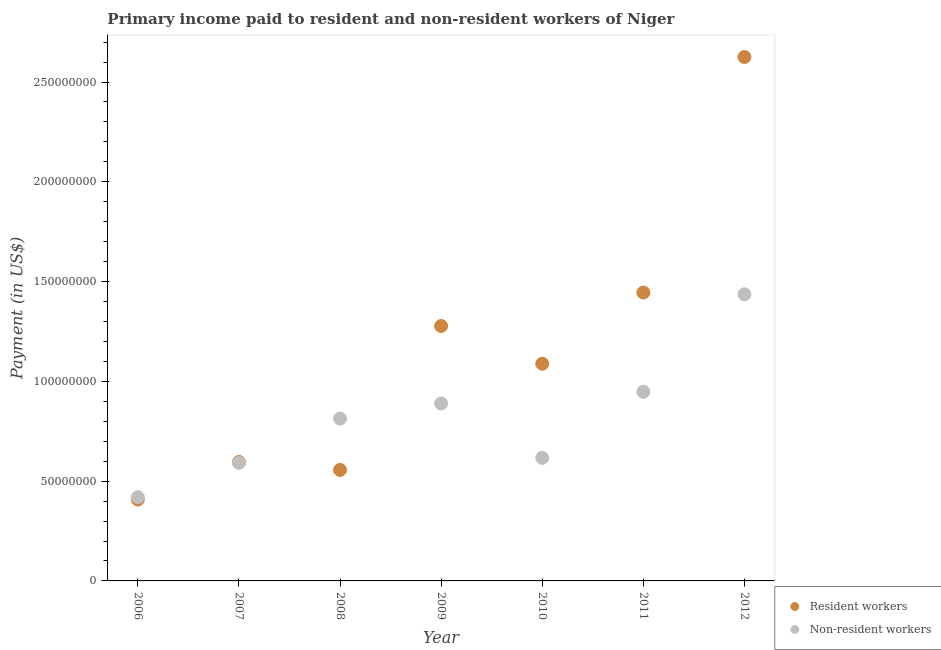How many different coloured dotlines are there?
Keep it short and to the point. 2. Is the number of dotlines equal to the number of legend labels?
Make the answer very short. Yes. What is the payment made to resident workers in 2012?
Provide a succinct answer. 2.63e+08. Across all years, what is the maximum payment made to non-resident workers?
Make the answer very short. 1.44e+08. Across all years, what is the minimum payment made to non-resident workers?
Make the answer very short. 4.20e+07. What is the total payment made to resident workers in the graph?
Give a very brief answer. 8.00e+08. What is the difference between the payment made to non-resident workers in 2007 and that in 2011?
Provide a succinct answer. -3.56e+07. What is the difference between the payment made to non-resident workers in 2007 and the payment made to resident workers in 2009?
Ensure brevity in your answer.  -6.86e+07. What is the average payment made to non-resident workers per year?
Ensure brevity in your answer.  8.17e+07. In the year 2011, what is the difference between the payment made to resident workers and payment made to non-resident workers?
Offer a terse response. 4.97e+07. What is the ratio of the payment made to non-resident workers in 2008 to that in 2010?
Give a very brief answer. 1.32. Is the difference between the payment made to resident workers in 2007 and 2008 greater than the difference between the payment made to non-resident workers in 2007 and 2008?
Offer a very short reply. Yes. What is the difference between the highest and the second highest payment made to resident workers?
Provide a short and direct response. 1.18e+08. What is the difference between the highest and the lowest payment made to non-resident workers?
Keep it short and to the point. 1.02e+08. Is the sum of the payment made to non-resident workers in 2009 and 2010 greater than the maximum payment made to resident workers across all years?
Make the answer very short. No. Is the payment made to non-resident workers strictly greater than the payment made to resident workers over the years?
Keep it short and to the point. No. How many dotlines are there?
Your answer should be compact. 2. What is the difference between two consecutive major ticks on the Y-axis?
Offer a terse response. 5.00e+07. Where does the legend appear in the graph?
Your answer should be compact. Bottom right. How many legend labels are there?
Offer a very short reply. 2. How are the legend labels stacked?
Keep it short and to the point. Vertical. What is the title of the graph?
Make the answer very short. Primary income paid to resident and non-resident workers of Niger. What is the label or title of the X-axis?
Keep it short and to the point. Year. What is the label or title of the Y-axis?
Ensure brevity in your answer.  Payment (in US$). What is the Payment (in US$) of Resident workers in 2006?
Your answer should be very brief. 4.08e+07. What is the Payment (in US$) of Non-resident workers in 2006?
Provide a succinct answer. 4.20e+07. What is the Payment (in US$) in Resident workers in 2007?
Your answer should be compact. 5.96e+07. What is the Payment (in US$) in Non-resident workers in 2007?
Your answer should be very brief. 5.92e+07. What is the Payment (in US$) of Resident workers in 2008?
Your response must be concise. 5.56e+07. What is the Payment (in US$) of Non-resident workers in 2008?
Provide a succinct answer. 8.13e+07. What is the Payment (in US$) in Resident workers in 2009?
Make the answer very short. 1.28e+08. What is the Payment (in US$) in Non-resident workers in 2009?
Offer a very short reply. 8.89e+07. What is the Payment (in US$) in Resident workers in 2010?
Your answer should be compact. 1.09e+08. What is the Payment (in US$) of Non-resident workers in 2010?
Ensure brevity in your answer.  6.17e+07. What is the Payment (in US$) of Resident workers in 2011?
Ensure brevity in your answer.  1.45e+08. What is the Payment (in US$) of Non-resident workers in 2011?
Offer a terse response. 9.48e+07. What is the Payment (in US$) in Resident workers in 2012?
Your answer should be compact. 2.63e+08. What is the Payment (in US$) of Non-resident workers in 2012?
Offer a very short reply. 1.44e+08. Across all years, what is the maximum Payment (in US$) of Resident workers?
Provide a succinct answer. 2.63e+08. Across all years, what is the maximum Payment (in US$) of Non-resident workers?
Provide a succinct answer. 1.44e+08. Across all years, what is the minimum Payment (in US$) of Resident workers?
Your answer should be very brief. 4.08e+07. Across all years, what is the minimum Payment (in US$) of Non-resident workers?
Your response must be concise. 4.20e+07. What is the total Payment (in US$) of Resident workers in the graph?
Your response must be concise. 8.00e+08. What is the total Payment (in US$) in Non-resident workers in the graph?
Provide a succinct answer. 5.72e+08. What is the difference between the Payment (in US$) of Resident workers in 2006 and that in 2007?
Your response must be concise. -1.89e+07. What is the difference between the Payment (in US$) of Non-resident workers in 2006 and that in 2007?
Make the answer very short. -1.72e+07. What is the difference between the Payment (in US$) in Resident workers in 2006 and that in 2008?
Ensure brevity in your answer.  -1.48e+07. What is the difference between the Payment (in US$) of Non-resident workers in 2006 and that in 2008?
Keep it short and to the point. -3.94e+07. What is the difference between the Payment (in US$) in Resident workers in 2006 and that in 2009?
Provide a succinct answer. -8.70e+07. What is the difference between the Payment (in US$) in Non-resident workers in 2006 and that in 2009?
Ensure brevity in your answer.  -4.70e+07. What is the difference between the Payment (in US$) in Resident workers in 2006 and that in 2010?
Provide a succinct answer. -6.81e+07. What is the difference between the Payment (in US$) of Non-resident workers in 2006 and that in 2010?
Provide a succinct answer. -1.97e+07. What is the difference between the Payment (in US$) of Resident workers in 2006 and that in 2011?
Your answer should be very brief. -1.04e+08. What is the difference between the Payment (in US$) in Non-resident workers in 2006 and that in 2011?
Give a very brief answer. -5.28e+07. What is the difference between the Payment (in US$) in Resident workers in 2006 and that in 2012?
Offer a very short reply. -2.22e+08. What is the difference between the Payment (in US$) in Non-resident workers in 2006 and that in 2012?
Offer a terse response. -1.02e+08. What is the difference between the Payment (in US$) of Resident workers in 2007 and that in 2008?
Your answer should be compact. 4.01e+06. What is the difference between the Payment (in US$) in Non-resident workers in 2007 and that in 2008?
Your response must be concise. -2.22e+07. What is the difference between the Payment (in US$) of Resident workers in 2007 and that in 2009?
Provide a succinct answer. -6.81e+07. What is the difference between the Payment (in US$) of Non-resident workers in 2007 and that in 2009?
Give a very brief answer. -2.98e+07. What is the difference between the Payment (in US$) in Resident workers in 2007 and that in 2010?
Offer a very short reply. -4.92e+07. What is the difference between the Payment (in US$) in Non-resident workers in 2007 and that in 2010?
Give a very brief answer. -2.50e+06. What is the difference between the Payment (in US$) in Resident workers in 2007 and that in 2011?
Make the answer very short. -8.49e+07. What is the difference between the Payment (in US$) of Non-resident workers in 2007 and that in 2011?
Your response must be concise. -3.56e+07. What is the difference between the Payment (in US$) in Resident workers in 2007 and that in 2012?
Provide a short and direct response. -2.03e+08. What is the difference between the Payment (in US$) of Non-resident workers in 2007 and that in 2012?
Provide a short and direct response. -8.44e+07. What is the difference between the Payment (in US$) in Resident workers in 2008 and that in 2009?
Ensure brevity in your answer.  -7.21e+07. What is the difference between the Payment (in US$) of Non-resident workers in 2008 and that in 2009?
Provide a succinct answer. -7.60e+06. What is the difference between the Payment (in US$) in Resident workers in 2008 and that in 2010?
Your answer should be compact. -5.32e+07. What is the difference between the Payment (in US$) in Non-resident workers in 2008 and that in 2010?
Make the answer very short. 1.96e+07. What is the difference between the Payment (in US$) in Resident workers in 2008 and that in 2011?
Offer a very short reply. -8.89e+07. What is the difference between the Payment (in US$) in Non-resident workers in 2008 and that in 2011?
Your response must be concise. -1.35e+07. What is the difference between the Payment (in US$) of Resident workers in 2008 and that in 2012?
Your response must be concise. -2.07e+08. What is the difference between the Payment (in US$) of Non-resident workers in 2008 and that in 2012?
Your response must be concise. -6.23e+07. What is the difference between the Payment (in US$) of Resident workers in 2009 and that in 2010?
Make the answer very short. 1.89e+07. What is the difference between the Payment (in US$) of Non-resident workers in 2009 and that in 2010?
Make the answer very short. 2.73e+07. What is the difference between the Payment (in US$) in Resident workers in 2009 and that in 2011?
Make the answer very short. -1.68e+07. What is the difference between the Payment (in US$) in Non-resident workers in 2009 and that in 2011?
Keep it short and to the point. -5.86e+06. What is the difference between the Payment (in US$) in Resident workers in 2009 and that in 2012?
Your answer should be very brief. -1.35e+08. What is the difference between the Payment (in US$) in Non-resident workers in 2009 and that in 2012?
Your answer should be very brief. -5.47e+07. What is the difference between the Payment (in US$) in Resident workers in 2010 and that in 2011?
Offer a terse response. -3.57e+07. What is the difference between the Payment (in US$) in Non-resident workers in 2010 and that in 2011?
Make the answer very short. -3.31e+07. What is the difference between the Payment (in US$) of Resident workers in 2010 and that in 2012?
Provide a succinct answer. -1.54e+08. What is the difference between the Payment (in US$) of Non-resident workers in 2010 and that in 2012?
Your answer should be compact. -8.19e+07. What is the difference between the Payment (in US$) of Resident workers in 2011 and that in 2012?
Your answer should be very brief. -1.18e+08. What is the difference between the Payment (in US$) in Non-resident workers in 2011 and that in 2012?
Give a very brief answer. -4.88e+07. What is the difference between the Payment (in US$) of Resident workers in 2006 and the Payment (in US$) of Non-resident workers in 2007?
Ensure brevity in your answer.  -1.84e+07. What is the difference between the Payment (in US$) of Resident workers in 2006 and the Payment (in US$) of Non-resident workers in 2008?
Make the answer very short. -4.06e+07. What is the difference between the Payment (in US$) of Resident workers in 2006 and the Payment (in US$) of Non-resident workers in 2009?
Keep it short and to the point. -4.82e+07. What is the difference between the Payment (in US$) of Resident workers in 2006 and the Payment (in US$) of Non-resident workers in 2010?
Ensure brevity in your answer.  -2.09e+07. What is the difference between the Payment (in US$) of Resident workers in 2006 and the Payment (in US$) of Non-resident workers in 2011?
Provide a short and direct response. -5.40e+07. What is the difference between the Payment (in US$) of Resident workers in 2006 and the Payment (in US$) of Non-resident workers in 2012?
Offer a terse response. -1.03e+08. What is the difference between the Payment (in US$) in Resident workers in 2007 and the Payment (in US$) in Non-resident workers in 2008?
Your answer should be very brief. -2.17e+07. What is the difference between the Payment (in US$) of Resident workers in 2007 and the Payment (in US$) of Non-resident workers in 2009?
Ensure brevity in your answer.  -2.93e+07. What is the difference between the Payment (in US$) in Resident workers in 2007 and the Payment (in US$) in Non-resident workers in 2010?
Ensure brevity in your answer.  -2.06e+06. What is the difference between the Payment (in US$) in Resident workers in 2007 and the Payment (in US$) in Non-resident workers in 2011?
Your answer should be compact. -3.52e+07. What is the difference between the Payment (in US$) of Resident workers in 2007 and the Payment (in US$) of Non-resident workers in 2012?
Provide a succinct answer. -8.40e+07. What is the difference between the Payment (in US$) of Resident workers in 2008 and the Payment (in US$) of Non-resident workers in 2009?
Your answer should be compact. -3.33e+07. What is the difference between the Payment (in US$) in Resident workers in 2008 and the Payment (in US$) in Non-resident workers in 2010?
Your response must be concise. -6.07e+06. What is the difference between the Payment (in US$) in Resident workers in 2008 and the Payment (in US$) in Non-resident workers in 2011?
Your answer should be very brief. -3.92e+07. What is the difference between the Payment (in US$) in Resident workers in 2008 and the Payment (in US$) in Non-resident workers in 2012?
Provide a succinct answer. -8.80e+07. What is the difference between the Payment (in US$) in Resident workers in 2009 and the Payment (in US$) in Non-resident workers in 2010?
Your response must be concise. 6.61e+07. What is the difference between the Payment (in US$) in Resident workers in 2009 and the Payment (in US$) in Non-resident workers in 2011?
Ensure brevity in your answer.  3.29e+07. What is the difference between the Payment (in US$) in Resident workers in 2009 and the Payment (in US$) in Non-resident workers in 2012?
Provide a short and direct response. -1.59e+07. What is the difference between the Payment (in US$) in Resident workers in 2010 and the Payment (in US$) in Non-resident workers in 2011?
Give a very brief answer. 1.41e+07. What is the difference between the Payment (in US$) of Resident workers in 2010 and the Payment (in US$) of Non-resident workers in 2012?
Provide a short and direct response. -3.48e+07. What is the difference between the Payment (in US$) of Resident workers in 2011 and the Payment (in US$) of Non-resident workers in 2012?
Your response must be concise. 8.73e+05. What is the average Payment (in US$) of Resident workers per year?
Make the answer very short. 1.14e+08. What is the average Payment (in US$) in Non-resident workers per year?
Give a very brief answer. 8.17e+07. In the year 2006, what is the difference between the Payment (in US$) of Resident workers and Payment (in US$) of Non-resident workers?
Provide a short and direct response. -1.21e+06. In the year 2007, what is the difference between the Payment (in US$) in Resident workers and Payment (in US$) in Non-resident workers?
Keep it short and to the point. 4.40e+05. In the year 2008, what is the difference between the Payment (in US$) of Resident workers and Payment (in US$) of Non-resident workers?
Offer a terse response. -2.57e+07. In the year 2009, what is the difference between the Payment (in US$) of Resident workers and Payment (in US$) of Non-resident workers?
Provide a succinct answer. 3.88e+07. In the year 2010, what is the difference between the Payment (in US$) of Resident workers and Payment (in US$) of Non-resident workers?
Your answer should be compact. 4.72e+07. In the year 2011, what is the difference between the Payment (in US$) in Resident workers and Payment (in US$) in Non-resident workers?
Make the answer very short. 4.97e+07. In the year 2012, what is the difference between the Payment (in US$) in Resident workers and Payment (in US$) in Non-resident workers?
Offer a very short reply. 1.19e+08. What is the ratio of the Payment (in US$) of Resident workers in 2006 to that in 2007?
Make the answer very short. 0.68. What is the ratio of the Payment (in US$) of Non-resident workers in 2006 to that in 2007?
Keep it short and to the point. 0.71. What is the ratio of the Payment (in US$) of Resident workers in 2006 to that in 2008?
Give a very brief answer. 0.73. What is the ratio of the Payment (in US$) of Non-resident workers in 2006 to that in 2008?
Offer a very short reply. 0.52. What is the ratio of the Payment (in US$) in Resident workers in 2006 to that in 2009?
Make the answer very short. 0.32. What is the ratio of the Payment (in US$) in Non-resident workers in 2006 to that in 2009?
Keep it short and to the point. 0.47. What is the ratio of the Payment (in US$) in Resident workers in 2006 to that in 2010?
Your response must be concise. 0.37. What is the ratio of the Payment (in US$) in Non-resident workers in 2006 to that in 2010?
Your response must be concise. 0.68. What is the ratio of the Payment (in US$) in Resident workers in 2006 to that in 2011?
Offer a very short reply. 0.28. What is the ratio of the Payment (in US$) in Non-resident workers in 2006 to that in 2011?
Provide a succinct answer. 0.44. What is the ratio of the Payment (in US$) in Resident workers in 2006 to that in 2012?
Provide a short and direct response. 0.16. What is the ratio of the Payment (in US$) in Non-resident workers in 2006 to that in 2012?
Provide a succinct answer. 0.29. What is the ratio of the Payment (in US$) of Resident workers in 2007 to that in 2008?
Provide a short and direct response. 1.07. What is the ratio of the Payment (in US$) of Non-resident workers in 2007 to that in 2008?
Your answer should be very brief. 0.73. What is the ratio of the Payment (in US$) in Resident workers in 2007 to that in 2009?
Make the answer very short. 0.47. What is the ratio of the Payment (in US$) of Non-resident workers in 2007 to that in 2009?
Make the answer very short. 0.67. What is the ratio of the Payment (in US$) of Resident workers in 2007 to that in 2010?
Provide a succinct answer. 0.55. What is the ratio of the Payment (in US$) in Non-resident workers in 2007 to that in 2010?
Your answer should be compact. 0.96. What is the ratio of the Payment (in US$) of Resident workers in 2007 to that in 2011?
Give a very brief answer. 0.41. What is the ratio of the Payment (in US$) in Non-resident workers in 2007 to that in 2011?
Offer a very short reply. 0.62. What is the ratio of the Payment (in US$) in Resident workers in 2007 to that in 2012?
Provide a short and direct response. 0.23. What is the ratio of the Payment (in US$) in Non-resident workers in 2007 to that in 2012?
Offer a very short reply. 0.41. What is the ratio of the Payment (in US$) in Resident workers in 2008 to that in 2009?
Give a very brief answer. 0.44. What is the ratio of the Payment (in US$) of Non-resident workers in 2008 to that in 2009?
Provide a succinct answer. 0.91. What is the ratio of the Payment (in US$) in Resident workers in 2008 to that in 2010?
Your answer should be very brief. 0.51. What is the ratio of the Payment (in US$) of Non-resident workers in 2008 to that in 2010?
Offer a very short reply. 1.32. What is the ratio of the Payment (in US$) in Resident workers in 2008 to that in 2011?
Your response must be concise. 0.38. What is the ratio of the Payment (in US$) of Non-resident workers in 2008 to that in 2011?
Your answer should be very brief. 0.86. What is the ratio of the Payment (in US$) of Resident workers in 2008 to that in 2012?
Offer a terse response. 0.21. What is the ratio of the Payment (in US$) of Non-resident workers in 2008 to that in 2012?
Provide a succinct answer. 0.57. What is the ratio of the Payment (in US$) in Resident workers in 2009 to that in 2010?
Ensure brevity in your answer.  1.17. What is the ratio of the Payment (in US$) in Non-resident workers in 2009 to that in 2010?
Offer a very short reply. 1.44. What is the ratio of the Payment (in US$) of Resident workers in 2009 to that in 2011?
Offer a terse response. 0.88. What is the ratio of the Payment (in US$) in Non-resident workers in 2009 to that in 2011?
Provide a short and direct response. 0.94. What is the ratio of the Payment (in US$) of Resident workers in 2009 to that in 2012?
Your answer should be very brief. 0.49. What is the ratio of the Payment (in US$) of Non-resident workers in 2009 to that in 2012?
Provide a short and direct response. 0.62. What is the ratio of the Payment (in US$) of Resident workers in 2010 to that in 2011?
Give a very brief answer. 0.75. What is the ratio of the Payment (in US$) of Non-resident workers in 2010 to that in 2011?
Your response must be concise. 0.65. What is the ratio of the Payment (in US$) in Resident workers in 2010 to that in 2012?
Provide a succinct answer. 0.41. What is the ratio of the Payment (in US$) in Non-resident workers in 2010 to that in 2012?
Your answer should be compact. 0.43. What is the ratio of the Payment (in US$) of Resident workers in 2011 to that in 2012?
Give a very brief answer. 0.55. What is the ratio of the Payment (in US$) of Non-resident workers in 2011 to that in 2012?
Provide a succinct answer. 0.66. What is the difference between the highest and the second highest Payment (in US$) of Resident workers?
Ensure brevity in your answer.  1.18e+08. What is the difference between the highest and the second highest Payment (in US$) of Non-resident workers?
Offer a terse response. 4.88e+07. What is the difference between the highest and the lowest Payment (in US$) of Resident workers?
Keep it short and to the point. 2.22e+08. What is the difference between the highest and the lowest Payment (in US$) of Non-resident workers?
Offer a very short reply. 1.02e+08. 